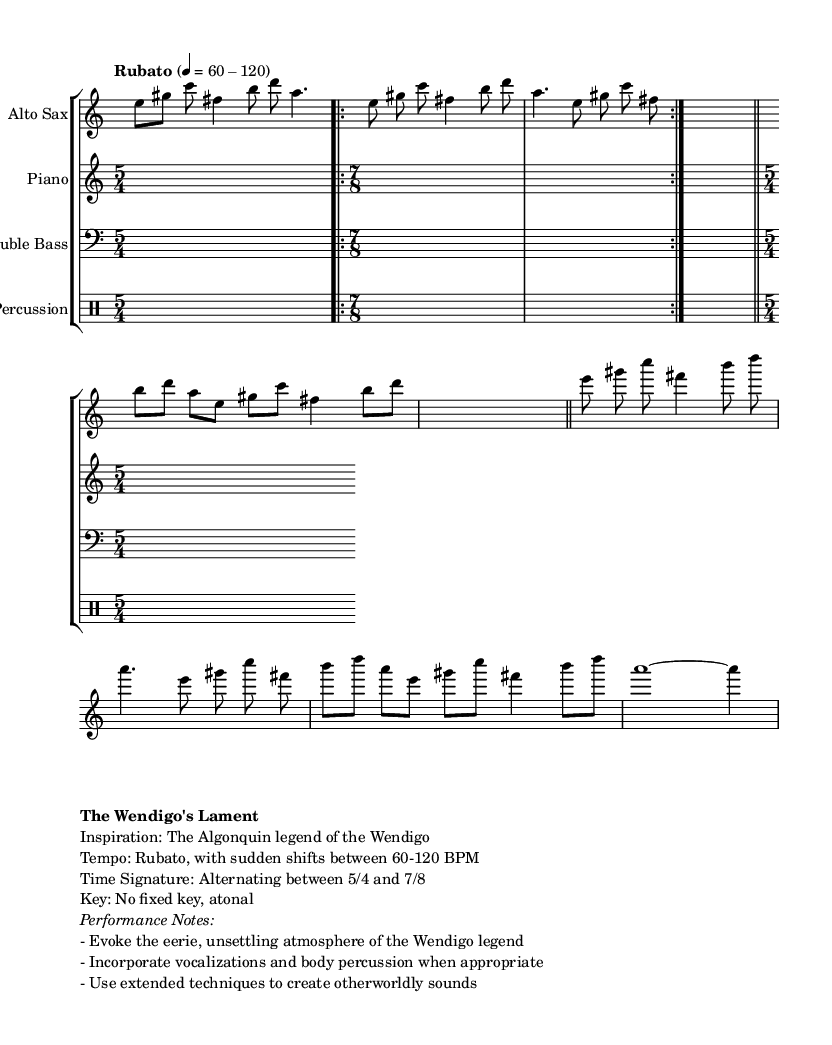What is the time signature of Theme A? The time signature for Theme A is indicated in the sheet music as 7/8, which is the time signature applied during that section.
Answer: 7/8 What tempo marking is used for the introduction? The introduction is marked as "Rubato," and the tempo is indicated with a range of 60-120 BPM. This means the performer has flexibility with the timing, staying within that BPM range.
Answer: Rubato, 60-120 BPM Which legend does this piece draw inspiration from? The piece is inspired by the Algonquin legend of the Wendigo, as noted in the markup section. This provides context for the emotional and thematic elements presented in the music.
Answer: Algonquin How many measures are there in the improvisation section? The improvisation section (cadenza) in this piece consists of three measures as indicated by separate rests representing the pause. This section allows for free expression without structured rhythm.
Answer: 3 What is the key signature used in this piece? The piece is noted to have no fixed key; it is described as atonal. This means it does not adhere to conventional key signatures, allowing for more freedom in composing.
Answer: Atonal What type of performance techniques are suggested in the performance notes? The performance notes suggest incorporating vocalizations and body percussion, as well as using extended techniques to create otherworldly sounds, which are characteristic of avant-garde jazz.
Answer: Vocalizations, body percussion, extended techniques 